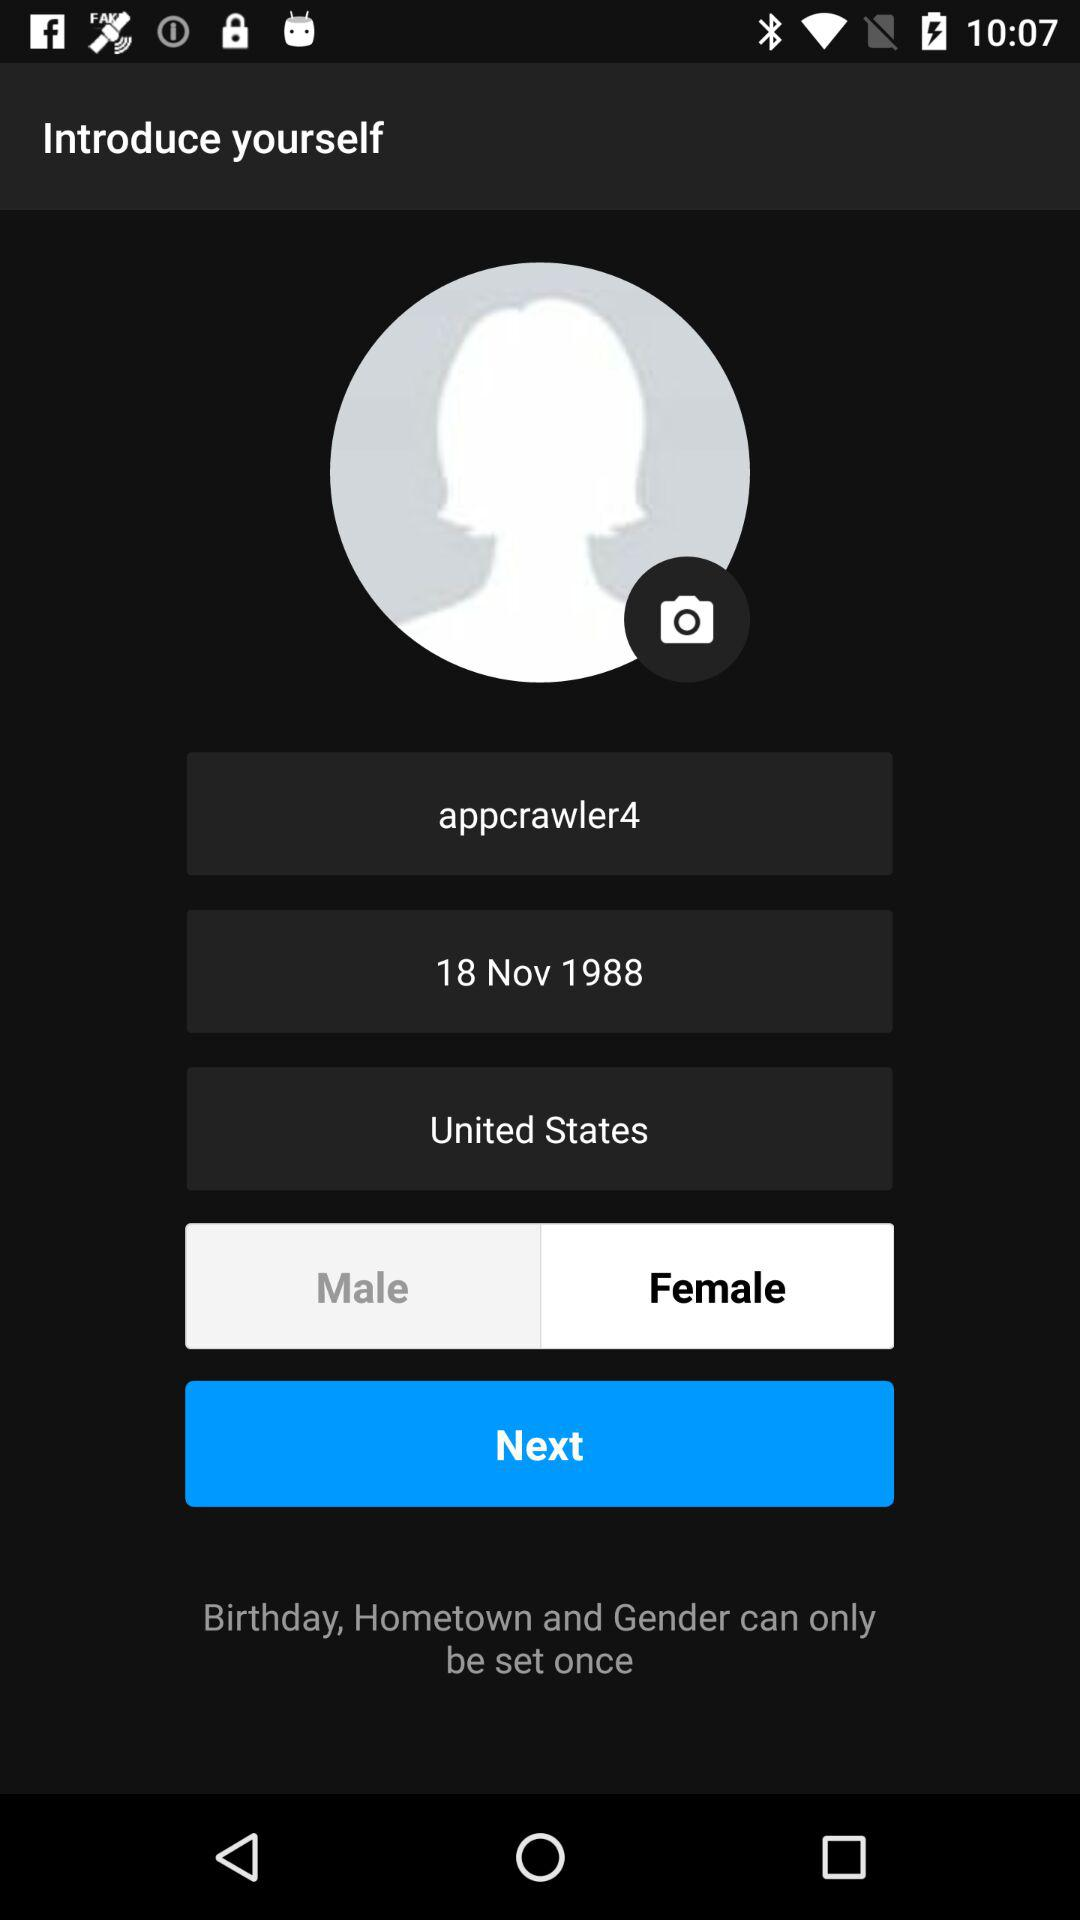What is the username? The username is "appcrawler4". 